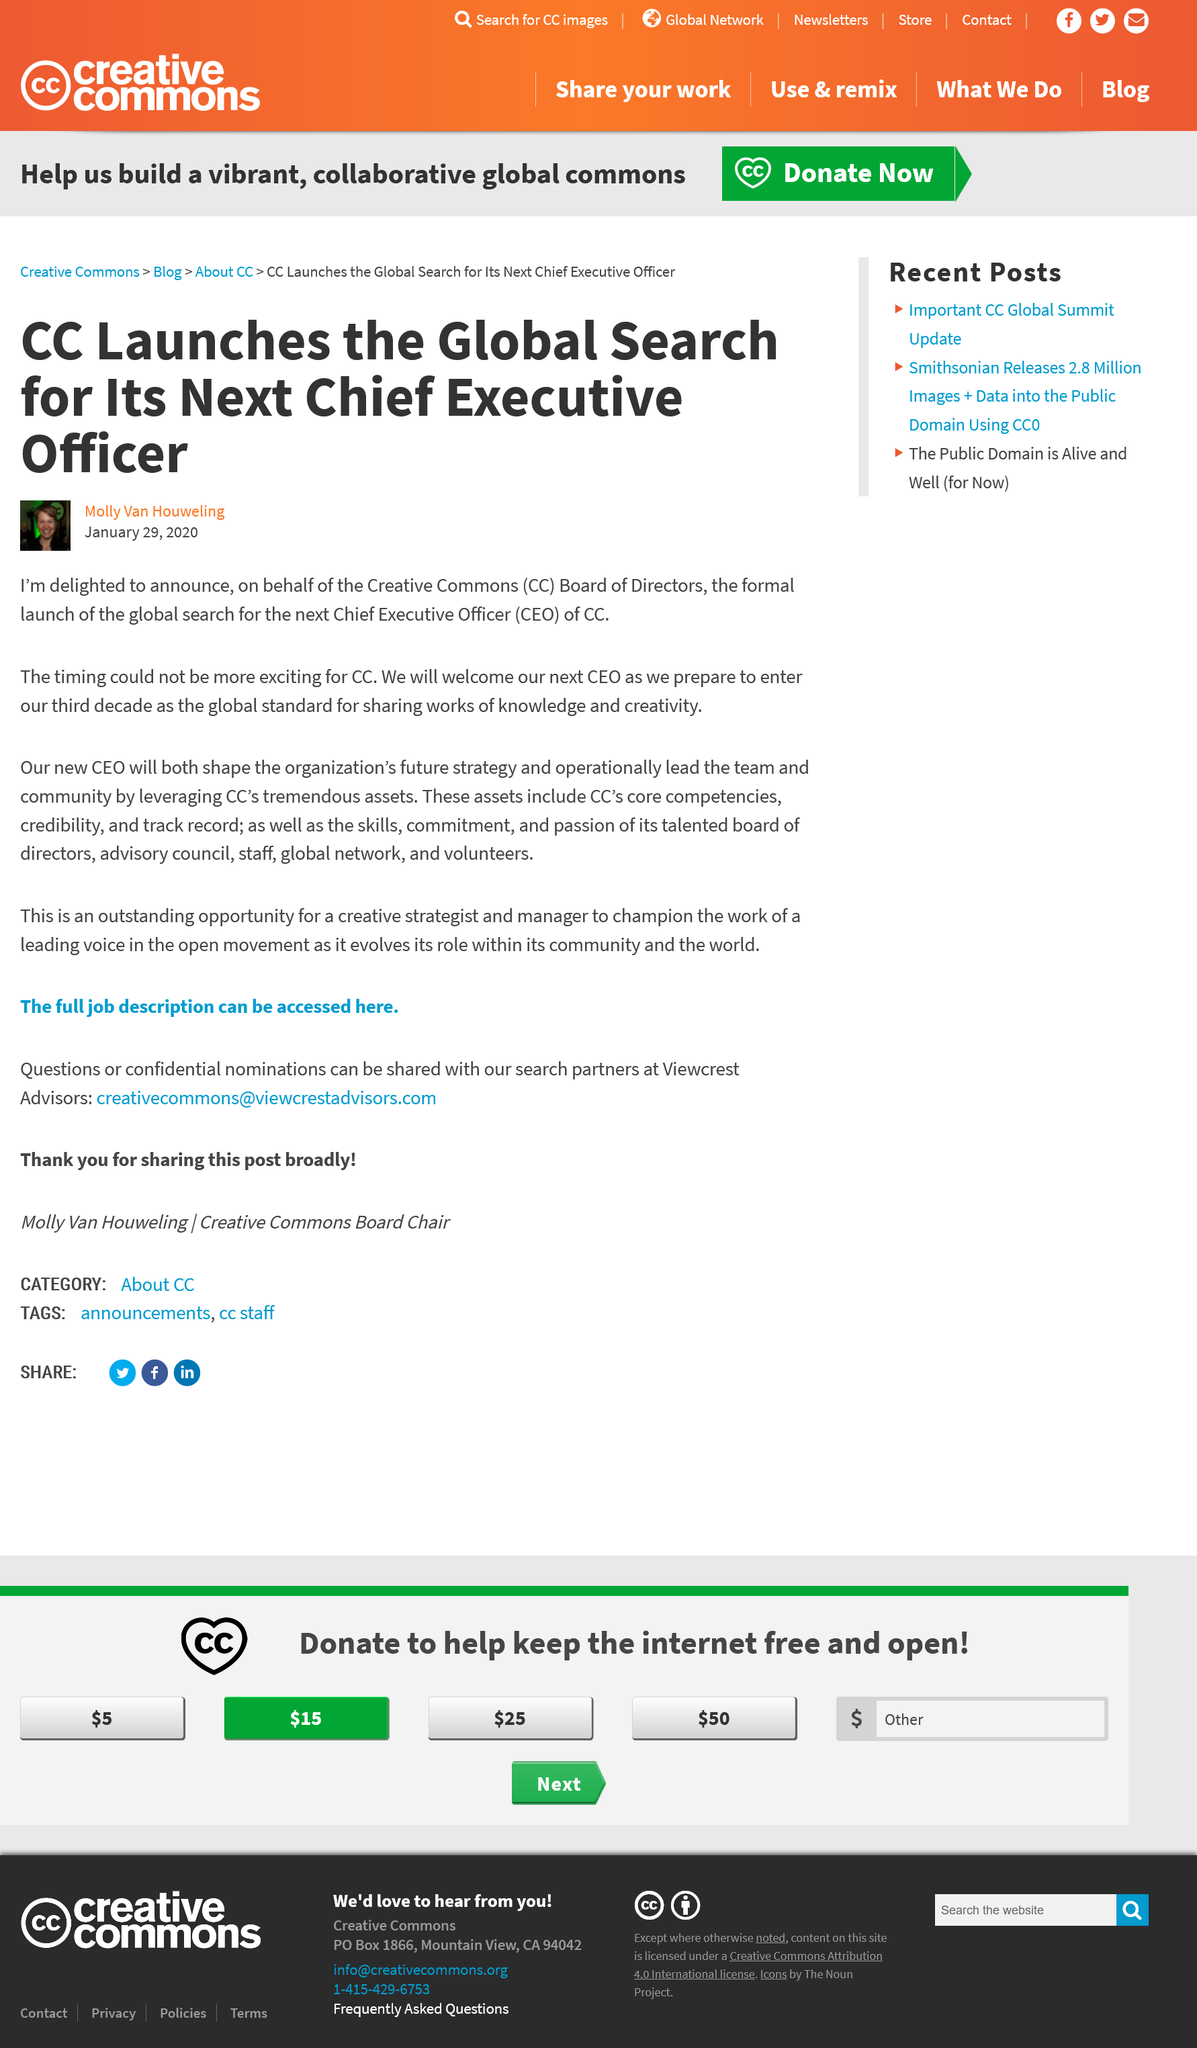Mention a couple of crucial points in this snapshot. For the past three decades, the global standard for communication has been CC, and it continues to be widely used in various industries. Creative Commons is an organization that provides free licenses for creators to share their work while retaining copyright. These licenses allow creators to give permission for others to use their work in certain ways, while also specifying any restrictions on that use. Creative Commons stands for an alternative to traditional copyright that enables the free sharing and use of creative work. The search for a new CEO began in January. 